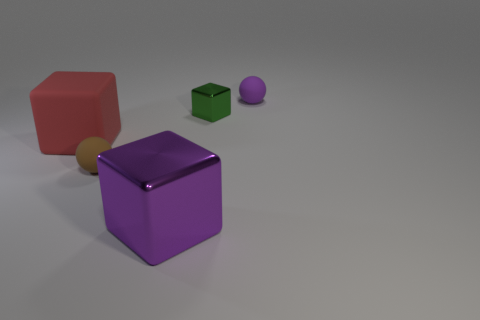What is the shape of the large rubber object?
Ensure brevity in your answer.  Cube. Is there a rubber thing that is in front of the small matte object in front of the tiny sphere that is right of the small metallic block?
Ensure brevity in your answer.  No. What color is the rubber ball on the left side of the small rubber thing that is right of the large thing in front of the rubber cube?
Make the answer very short. Brown. There is a purple object that is the same shape as the large red rubber thing; what material is it?
Your response must be concise. Metal. How big is the rubber ball on the right side of the small matte ball that is left of the purple ball?
Give a very brief answer. Small. There is a large thing right of the brown sphere; what is its material?
Keep it short and to the point. Metal. What is the size of the red object that is made of the same material as the small purple sphere?
Your response must be concise. Large. How many tiny matte objects have the same shape as the small metallic object?
Give a very brief answer. 0. Do the purple matte object and the tiny rubber thing in front of the purple rubber sphere have the same shape?
Offer a terse response. Yes. There is a small object that is the same color as the large metallic object; what shape is it?
Your answer should be very brief. Sphere. 